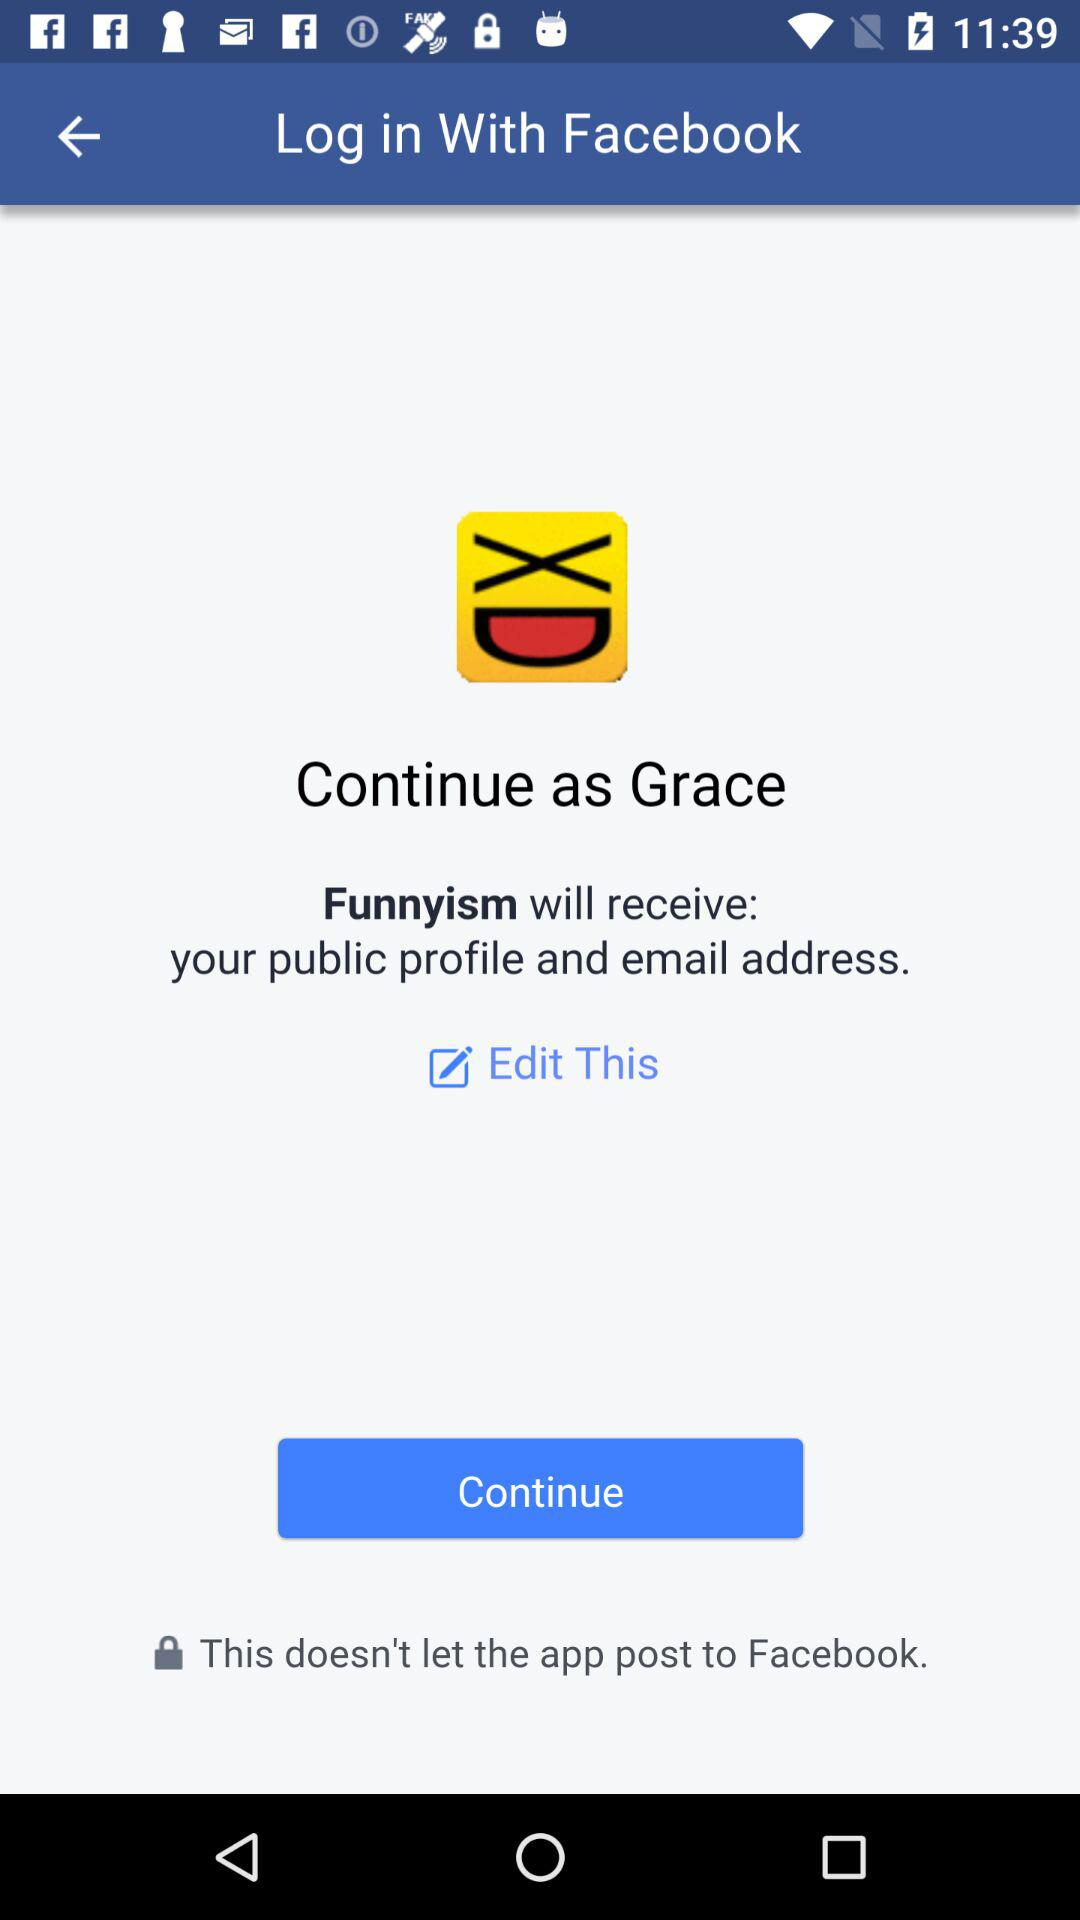What application is asking for permission? The application asking for permission is "Funnyism". 